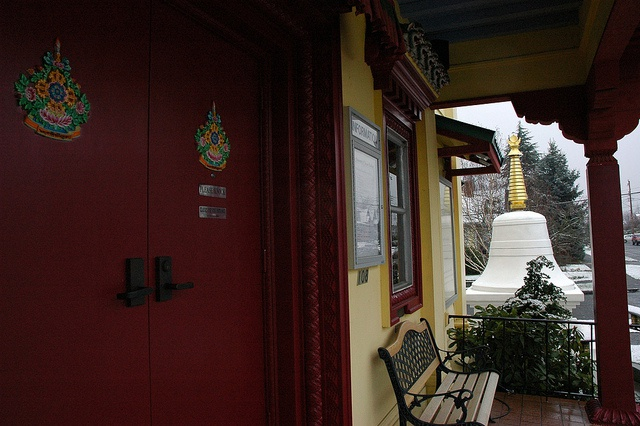Describe the objects in this image and their specific colors. I can see a bench in black, gray, and olive tones in this image. 